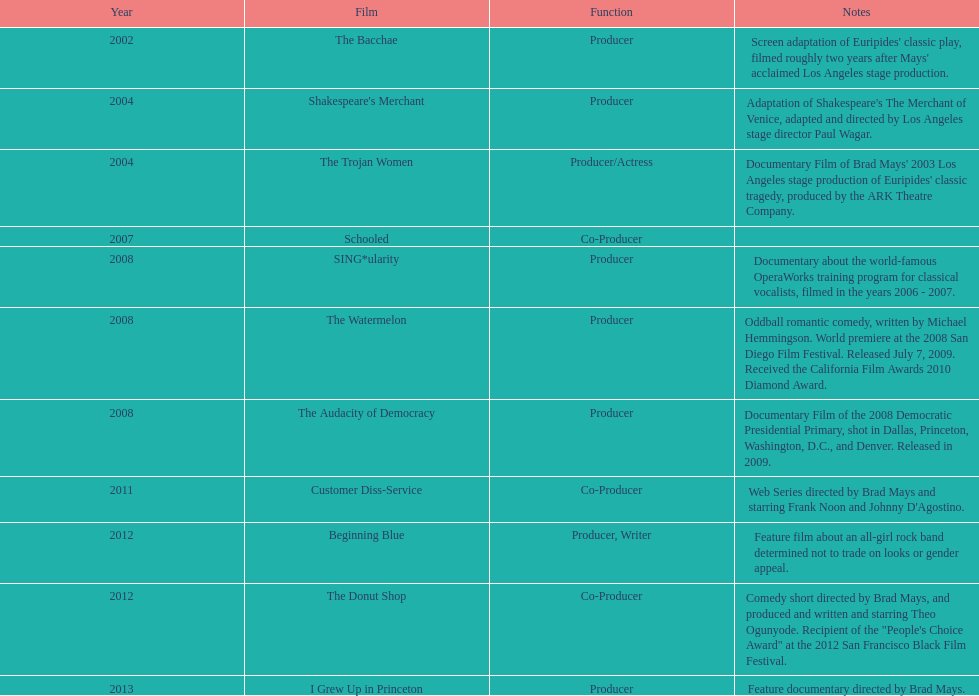Who was the first producer that made the film sing*ularity? Lorenda Starfelt. 